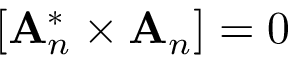<formula> <loc_0><loc_0><loc_500><loc_500>\left [ { A } _ { n } ^ { * } \times { A } _ { n } \right ] = 0</formula> 